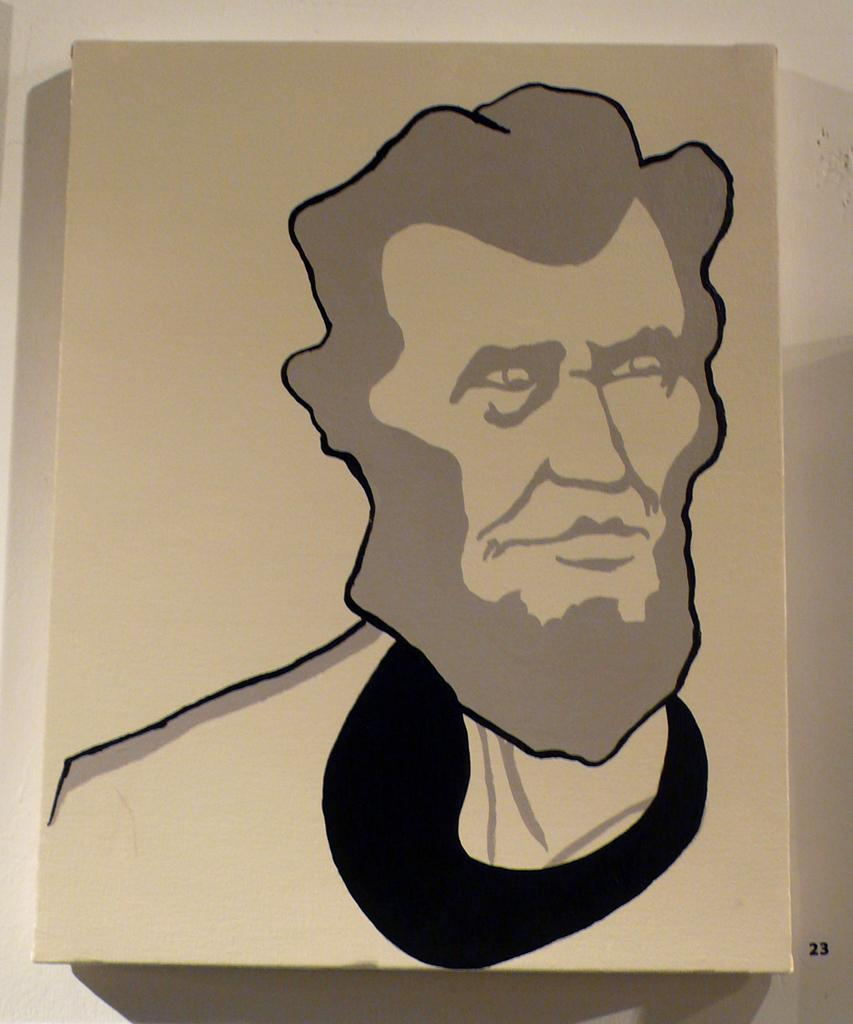What is the main object in the center of the image? There is a board in the center of the image. What is depicted on the board? There is some art on the board. What color is the background of the image? The background is white in color. What type of substance is being used to create the art on the board? There is no information provided about the substance used to create the art on the board. How many apples are visible in the image? There are no apples present in the image. 